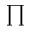<formula> <loc_0><loc_0><loc_500><loc_500>\prod</formula> 